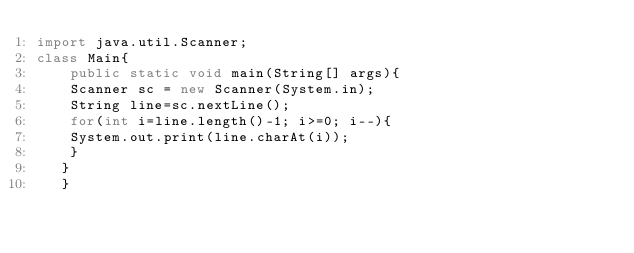Convert code to text. <code><loc_0><loc_0><loc_500><loc_500><_Java_>import java.util.Scanner;
class Main{
    public static void main(String[] args){
    Scanner sc = new Scanner(System.in);
    String line=sc.nextLine();
    for(int i=line.length()-1; i>=0; i--){
    System.out.print(line.charAt(i));
    }
   }
   }
    </code> 